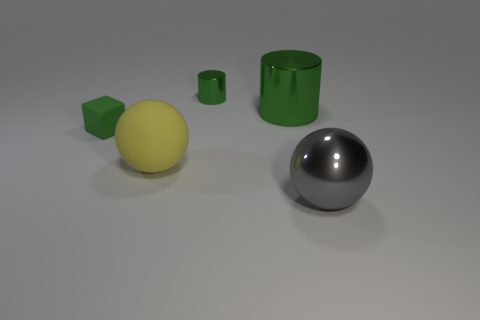The metallic thing that is in front of the large shiny thing that is behind the metallic object that is in front of the large yellow thing is what color? gray 